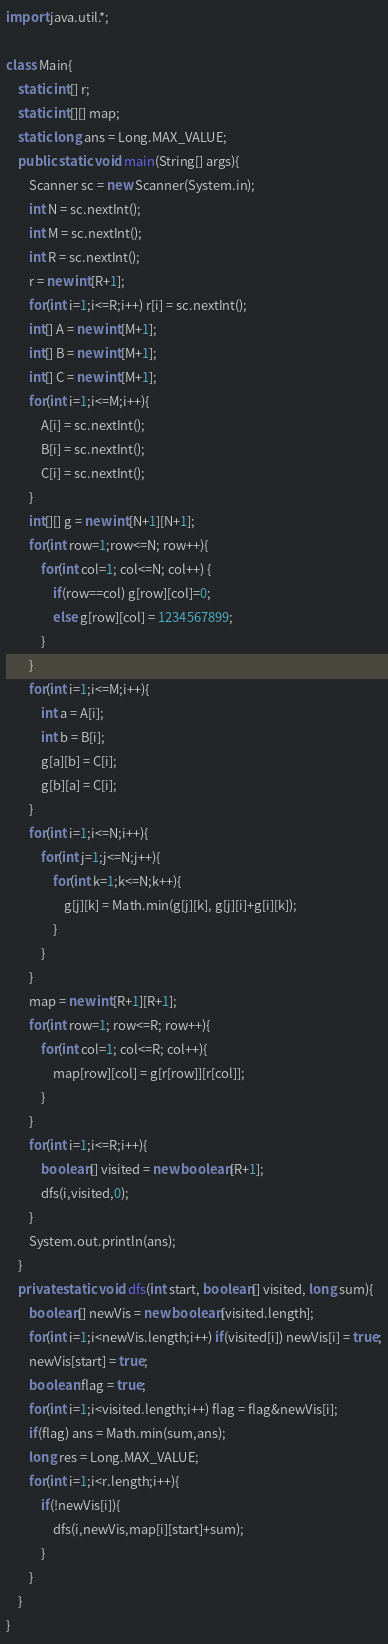<code> <loc_0><loc_0><loc_500><loc_500><_Java_>import java.util.*;

class Main{
    static int[] r;
    static int[][] map;
    static long ans = Long.MAX_VALUE;
    public static void main(String[] args){
        Scanner sc = new Scanner(System.in);
        int N = sc.nextInt();
        int M = sc.nextInt();
        int R = sc.nextInt();
        r = new int[R+1];
        for(int i=1;i<=R;i++) r[i] = sc.nextInt();
        int[] A = new int[M+1];
        int[] B = new int[M+1];
        int[] C = new int[M+1];
        for(int i=1;i<=M;i++){
            A[i] = sc.nextInt();
            B[i] = sc.nextInt();
            C[i] = sc.nextInt();
        }
        int[][] g = new int[N+1][N+1];
        for(int row=1;row<=N; row++){
            for(int col=1; col<=N; col++) {
                if(row==col) g[row][col]=0;
                else g[row][col] = 1234567899;
            }
        }
        for(int i=1;i<=M;i++){
            int a = A[i];
            int b = B[i];
            g[a][b] = C[i];
            g[b][a] = C[i];
        }
        for(int i=1;i<=N;i++){
            for(int j=1;j<=N;j++){
                for(int k=1;k<=N;k++){
                    g[j][k] = Math.min(g[j][k], g[j][i]+g[i][k]);
                }
            }
        }
        map = new int[R+1][R+1];
        for(int row=1; row<=R; row++){
            for(int col=1; col<=R; col++){
                map[row][col] = g[r[row]][r[col]];
            }
        }
        for(int i=1;i<=R;i++){
            boolean[] visited = new boolean[R+1];
            dfs(i,visited,0);
        }
        System.out.println(ans);
    }
    private static void dfs(int start, boolean[] visited, long sum){
        boolean[] newVis = new boolean[visited.length];
        for(int i=1;i<newVis.length;i++) if(visited[i]) newVis[i] = true;
        newVis[start] = true;
        boolean flag = true;
        for(int i=1;i<visited.length;i++) flag = flag&newVis[i];
        if(flag) ans = Math.min(sum,ans);
        long res = Long.MAX_VALUE;
        for(int i=1;i<r.length;i++){
            if(!newVis[i]){
                dfs(i,newVis,map[i][start]+sum);
            }
        }
    }
}
</code> 